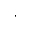Convert formula to latex. <formula><loc_0><loc_0><loc_500><loc_500>\cdot</formula> 